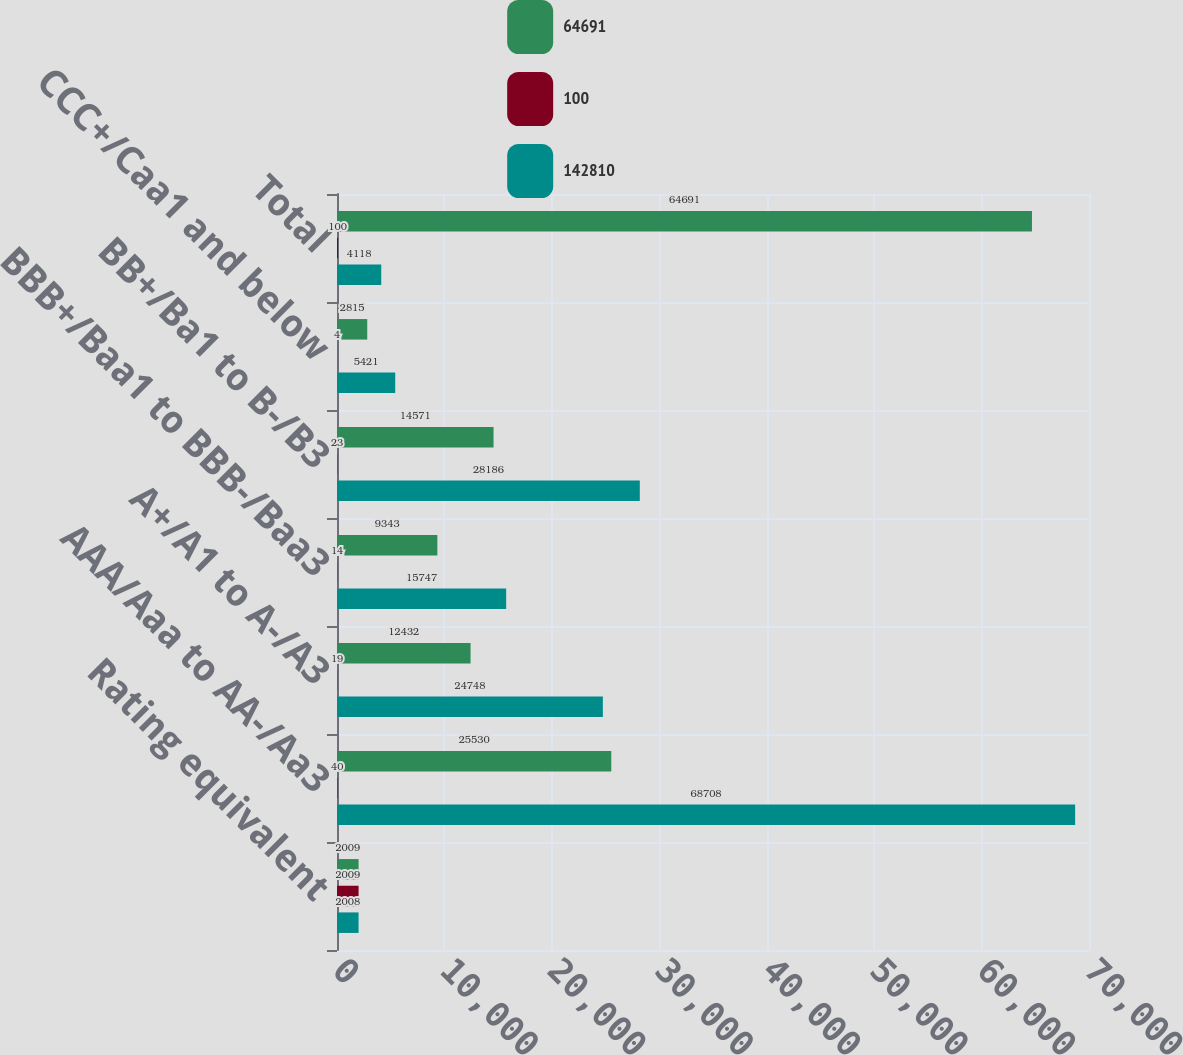Convert chart to OTSL. <chart><loc_0><loc_0><loc_500><loc_500><stacked_bar_chart><ecel><fcel>Rating equivalent<fcel>AAA/Aaa to AA-/Aa3<fcel>A+/A1 to A-/A3<fcel>BBB+/Baa1 to BBB-/Baa3<fcel>BB+/Ba1 to B-/B3<fcel>CCC+/Caa1 and below<fcel>Total<nl><fcel>64691<fcel>2009<fcel>25530<fcel>12432<fcel>9343<fcel>14571<fcel>2815<fcel>64691<nl><fcel>100<fcel>2009<fcel>40<fcel>19<fcel>14<fcel>23<fcel>4<fcel>100<nl><fcel>142810<fcel>2008<fcel>68708<fcel>24748<fcel>15747<fcel>28186<fcel>5421<fcel>4118<nl></chart> 